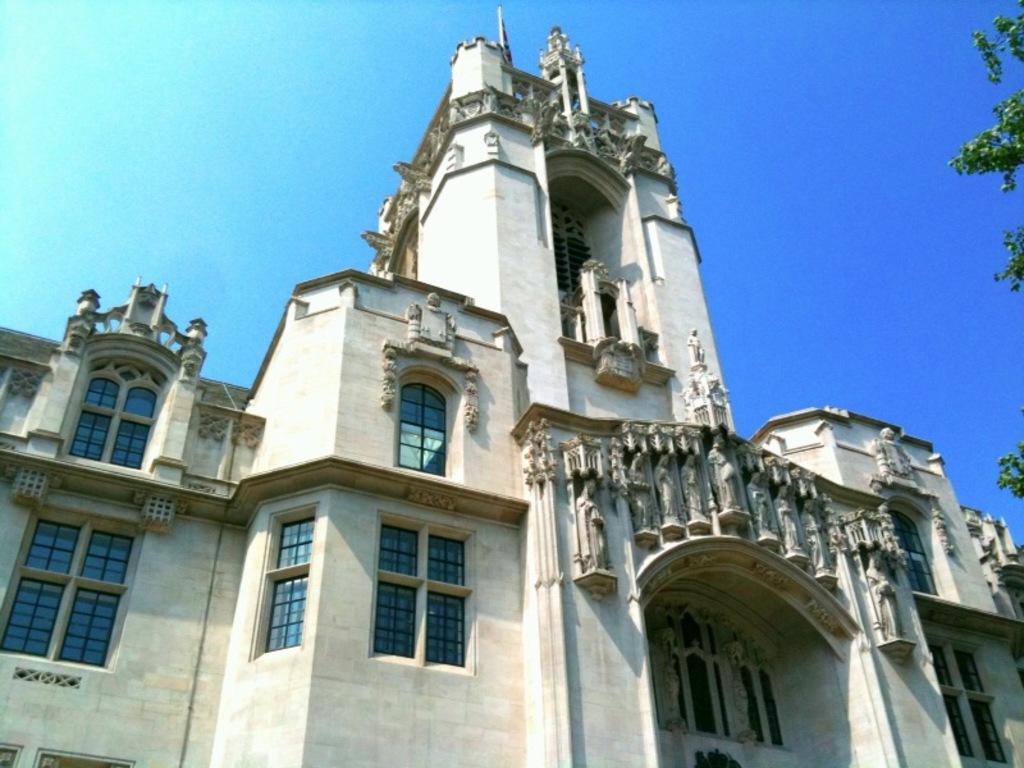Describe this image in one or two sentences. This is an outside view. Here I can see a building along with the windows. On the right side few leaves are visible. At the top of the image I can see the sky. 